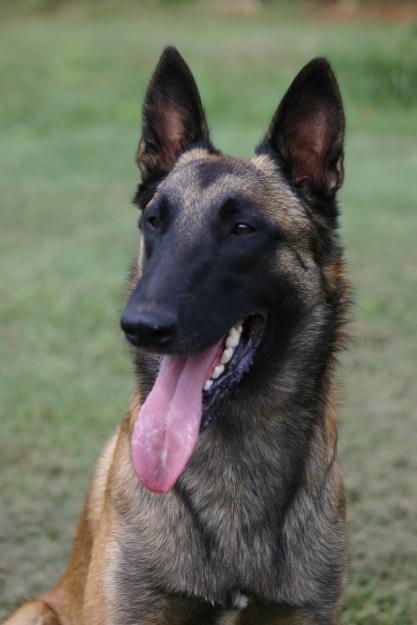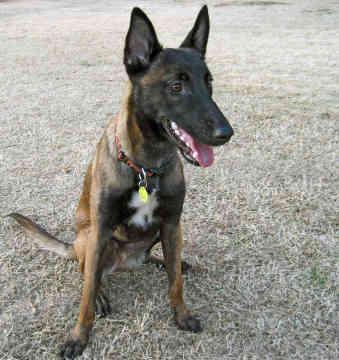The first image is the image on the left, the second image is the image on the right. Examine the images to the left and right. Is the description "None of the dogs has their mouths open." accurate? Answer yes or no. No. The first image is the image on the left, the second image is the image on the right. For the images displayed, is the sentence "The dog in the right image is sitting upright, with head turned leftward." factually correct? Answer yes or no. No. 